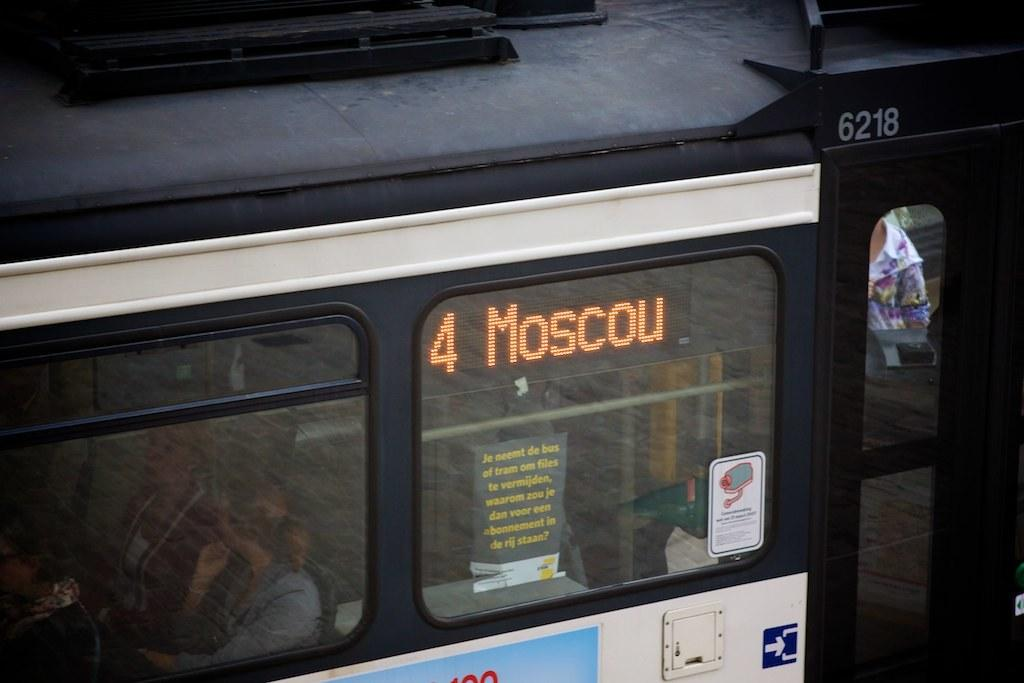<image>
Render a clear and concise summary of the photo. a bus that has 4 Moscow on it and people in it 